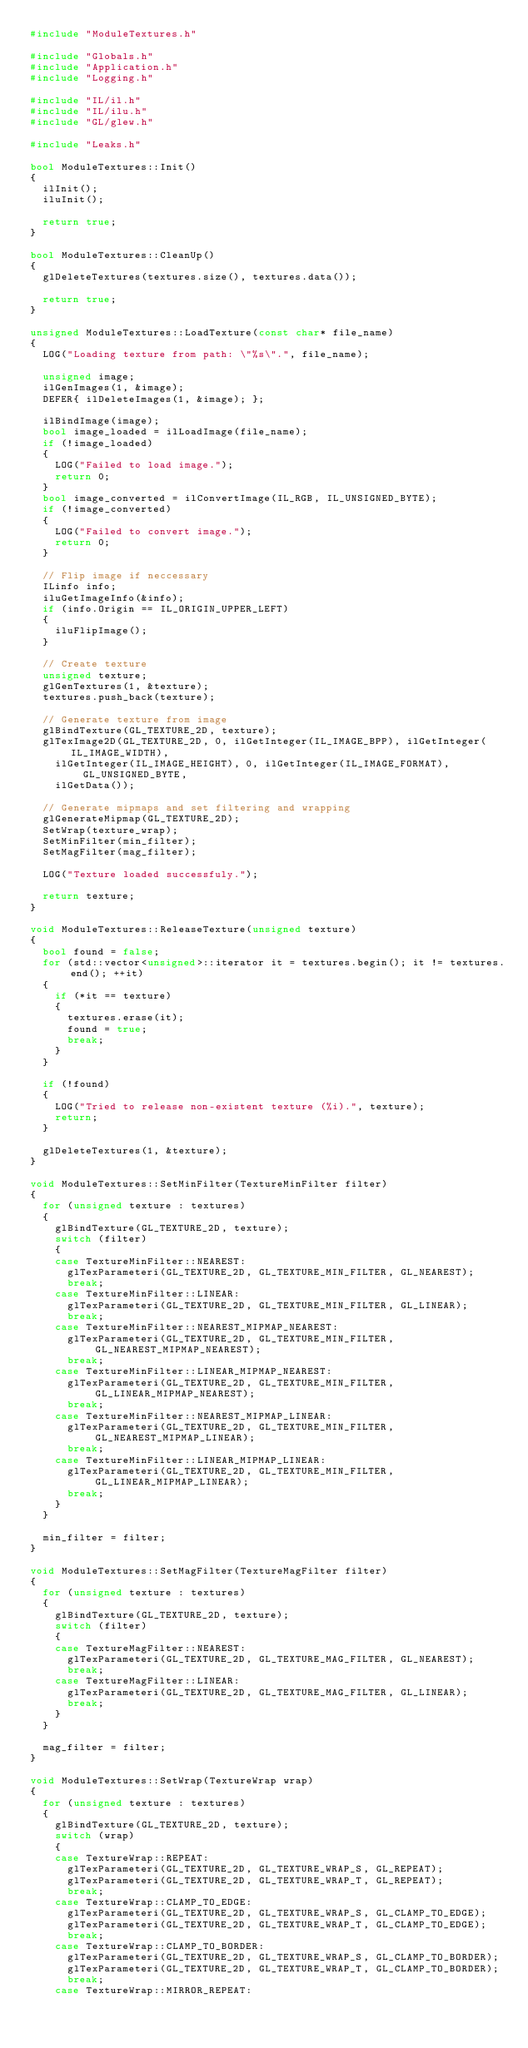Convert code to text. <code><loc_0><loc_0><loc_500><loc_500><_C++_>#include "ModuleTextures.h"

#include "Globals.h"
#include "Application.h"
#include "Logging.h"

#include "IL/il.h"
#include "IL/ilu.h"
#include "GL/glew.h"

#include "Leaks.h"

bool ModuleTextures::Init()
{
	ilInit();
	iluInit();

	return true;
}

bool ModuleTextures::CleanUp()
{
	glDeleteTextures(textures.size(), textures.data());

	return true;
}

unsigned ModuleTextures::LoadTexture(const char* file_name)
{
	LOG("Loading texture from path: \"%s\".", file_name);

	unsigned image;
	ilGenImages(1, &image);
	DEFER{ ilDeleteImages(1, &image); };

	ilBindImage(image);
	bool image_loaded = ilLoadImage(file_name);
	if (!image_loaded)
	{
		LOG("Failed to load image.");
		return 0;
	}
	bool image_converted = ilConvertImage(IL_RGB, IL_UNSIGNED_BYTE);
	if (!image_converted)
	{
		LOG("Failed to convert image.");
		return 0;
	}

	// Flip image if neccessary
	ILinfo info;
	iluGetImageInfo(&info);
	if (info.Origin == IL_ORIGIN_UPPER_LEFT)
	{
		iluFlipImage();
	}

	// Create texture
	unsigned texture;
	glGenTextures(1, &texture);
	textures.push_back(texture);

	// Generate texture from image
	glBindTexture(GL_TEXTURE_2D, texture);
	glTexImage2D(GL_TEXTURE_2D, 0, ilGetInteger(IL_IMAGE_BPP), ilGetInteger(IL_IMAGE_WIDTH),
		ilGetInteger(IL_IMAGE_HEIGHT), 0, ilGetInteger(IL_IMAGE_FORMAT), GL_UNSIGNED_BYTE,
		ilGetData());

	// Generate mipmaps and set filtering and wrapping
	glGenerateMipmap(GL_TEXTURE_2D);
	SetWrap(texture_wrap);
	SetMinFilter(min_filter);
	SetMagFilter(mag_filter);

	LOG("Texture loaded successfuly.");

	return texture;
}

void ModuleTextures::ReleaseTexture(unsigned texture)
{
	bool found = false;
	for (std::vector<unsigned>::iterator it = textures.begin(); it != textures.end(); ++it)
	{
		if (*it == texture)
		{
			textures.erase(it);
			found = true;
			break;
		}
	}

	if (!found)
	{
		LOG("Tried to release non-existent texture (%i).", texture);
		return;
	}

	glDeleteTextures(1, &texture);
}

void ModuleTextures::SetMinFilter(TextureMinFilter filter)
{
	for (unsigned texture : textures)
	{
		glBindTexture(GL_TEXTURE_2D, texture);
		switch (filter)
		{
		case TextureMinFilter::NEAREST:
			glTexParameteri(GL_TEXTURE_2D, GL_TEXTURE_MIN_FILTER, GL_NEAREST);
			break;
		case TextureMinFilter::LINEAR:
			glTexParameteri(GL_TEXTURE_2D, GL_TEXTURE_MIN_FILTER, GL_LINEAR);
			break;
		case TextureMinFilter::NEAREST_MIPMAP_NEAREST:
			glTexParameteri(GL_TEXTURE_2D, GL_TEXTURE_MIN_FILTER, GL_NEAREST_MIPMAP_NEAREST);
			break;
		case TextureMinFilter::LINEAR_MIPMAP_NEAREST:
			glTexParameteri(GL_TEXTURE_2D, GL_TEXTURE_MIN_FILTER, GL_LINEAR_MIPMAP_NEAREST);
			break;
		case TextureMinFilter::NEAREST_MIPMAP_LINEAR:
			glTexParameteri(GL_TEXTURE_2D, GL_TEXTURE_MIN_FILTER, GL_NEAREST_MIPMAP_LINEAR);
			break;
		case TextureMinFilter::LINEAR_MIPMAP_LINEAR:
			glTexParameteri(GL_TEXTURE_2D, GL_TEXTURE_MIN_FILTER, GL_LINEAR_MIPMAP_LINEAR);
			break;
		}
	}

	min_filter = filter;
}

void ModuleTextures::SetMagFilter(TextureMagFilter filter)
{
	for (unsigned texture : textures)
	{
		glBindTexture(GL_TEXTURE_2D, texture);
		switch (filter)
		{
		case TextureMagFilter::NEAREST:
			glTexParameteri(GL_TEXTURE_2D, GL_TEXTURE_MAG_FILTER, GL_NEAREST);
			break;
		case TextureMagFilter::LINEAR:
			glTexParameteri(GL_TEXTURE_2D, GL_TEXTURE_MAG_FILTER, GL_LINEAR);
			break;
		}
	}

	mag_filter = filter;
}

void ModuleTextures::SetWrap(TextureWrap wrap)
{
	for (unsigned texture : textures)
	{
		glBindTexture(GL_TEXTURE_2D, texture);
		switch (wrap)
		{
		case TextureWrap::REPEAT:
			glTexParameteri(GL_TEXTURE_2D, GL_TEXTURE_WRAP_S, GL_REPEAT);
			glTexParameteri(GL_TEXTURE_2D, GL_TEXTURE_WRAP_T, GL_REPEAT);
			break;
		case TextureWrap::CLAMP_TO_EDGE:
			glTexParameteri(GL_TEXTURE_2D, GL_TEXTURE_WRAP_S, GL_CLAMP_TO_EDGE);
			glTexParameteri(GL_TEXTURE_2D, GL_TEXTURE_WRAP_T, GL_CLAMP_TO_EDGE);
			break;
		case TextureWrap::CLAMP_TO_BORDER:
			glTexParameteri(GL_TEXTURE_2D, GL_TEXTURE_WRAP_S, GL_CLAMP_TO_BORDER);
			glTexParameteri(GL_TEXTURE_2D, GL_TEXTURE_WRAP_T, GL_CLAMP_TO_BORDER);
			break;
		case TextureWrap::MIRROR_REPEAT:</code> 